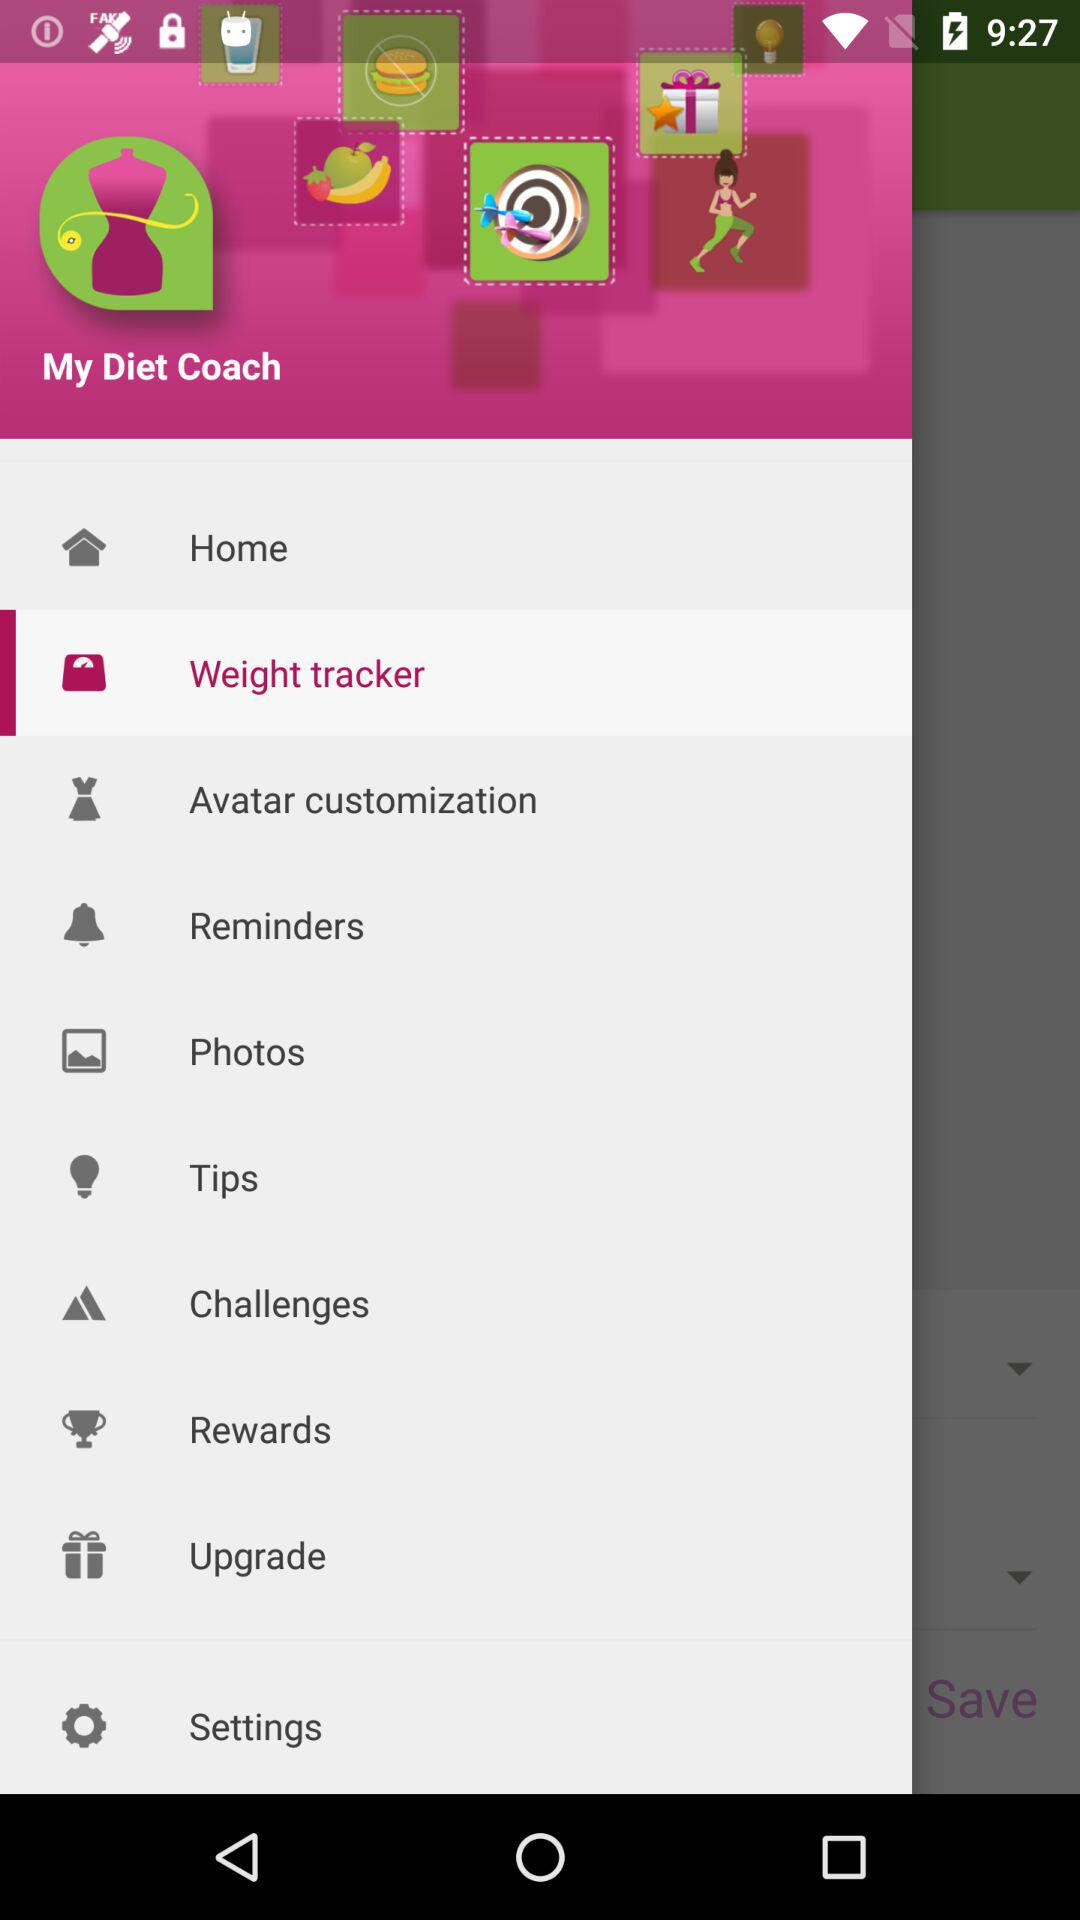Which item is selected? The selected item is "Weight tracker". 